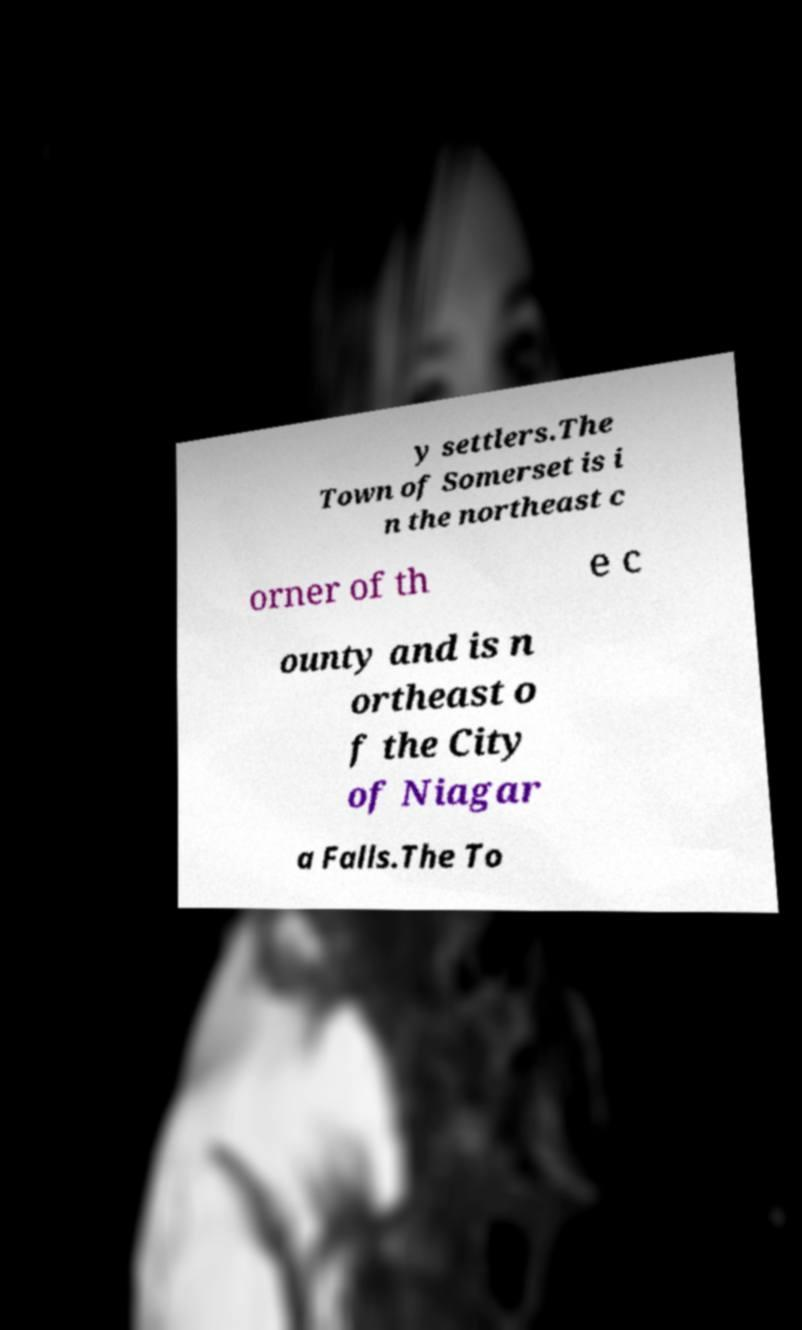Please read and relay the text visible in this image. What does it say? y settlers.The Town of Somerset is i n the northeast c orner of th e c ounty and is n ortheast o f the City of Niagar a Falls.The To 